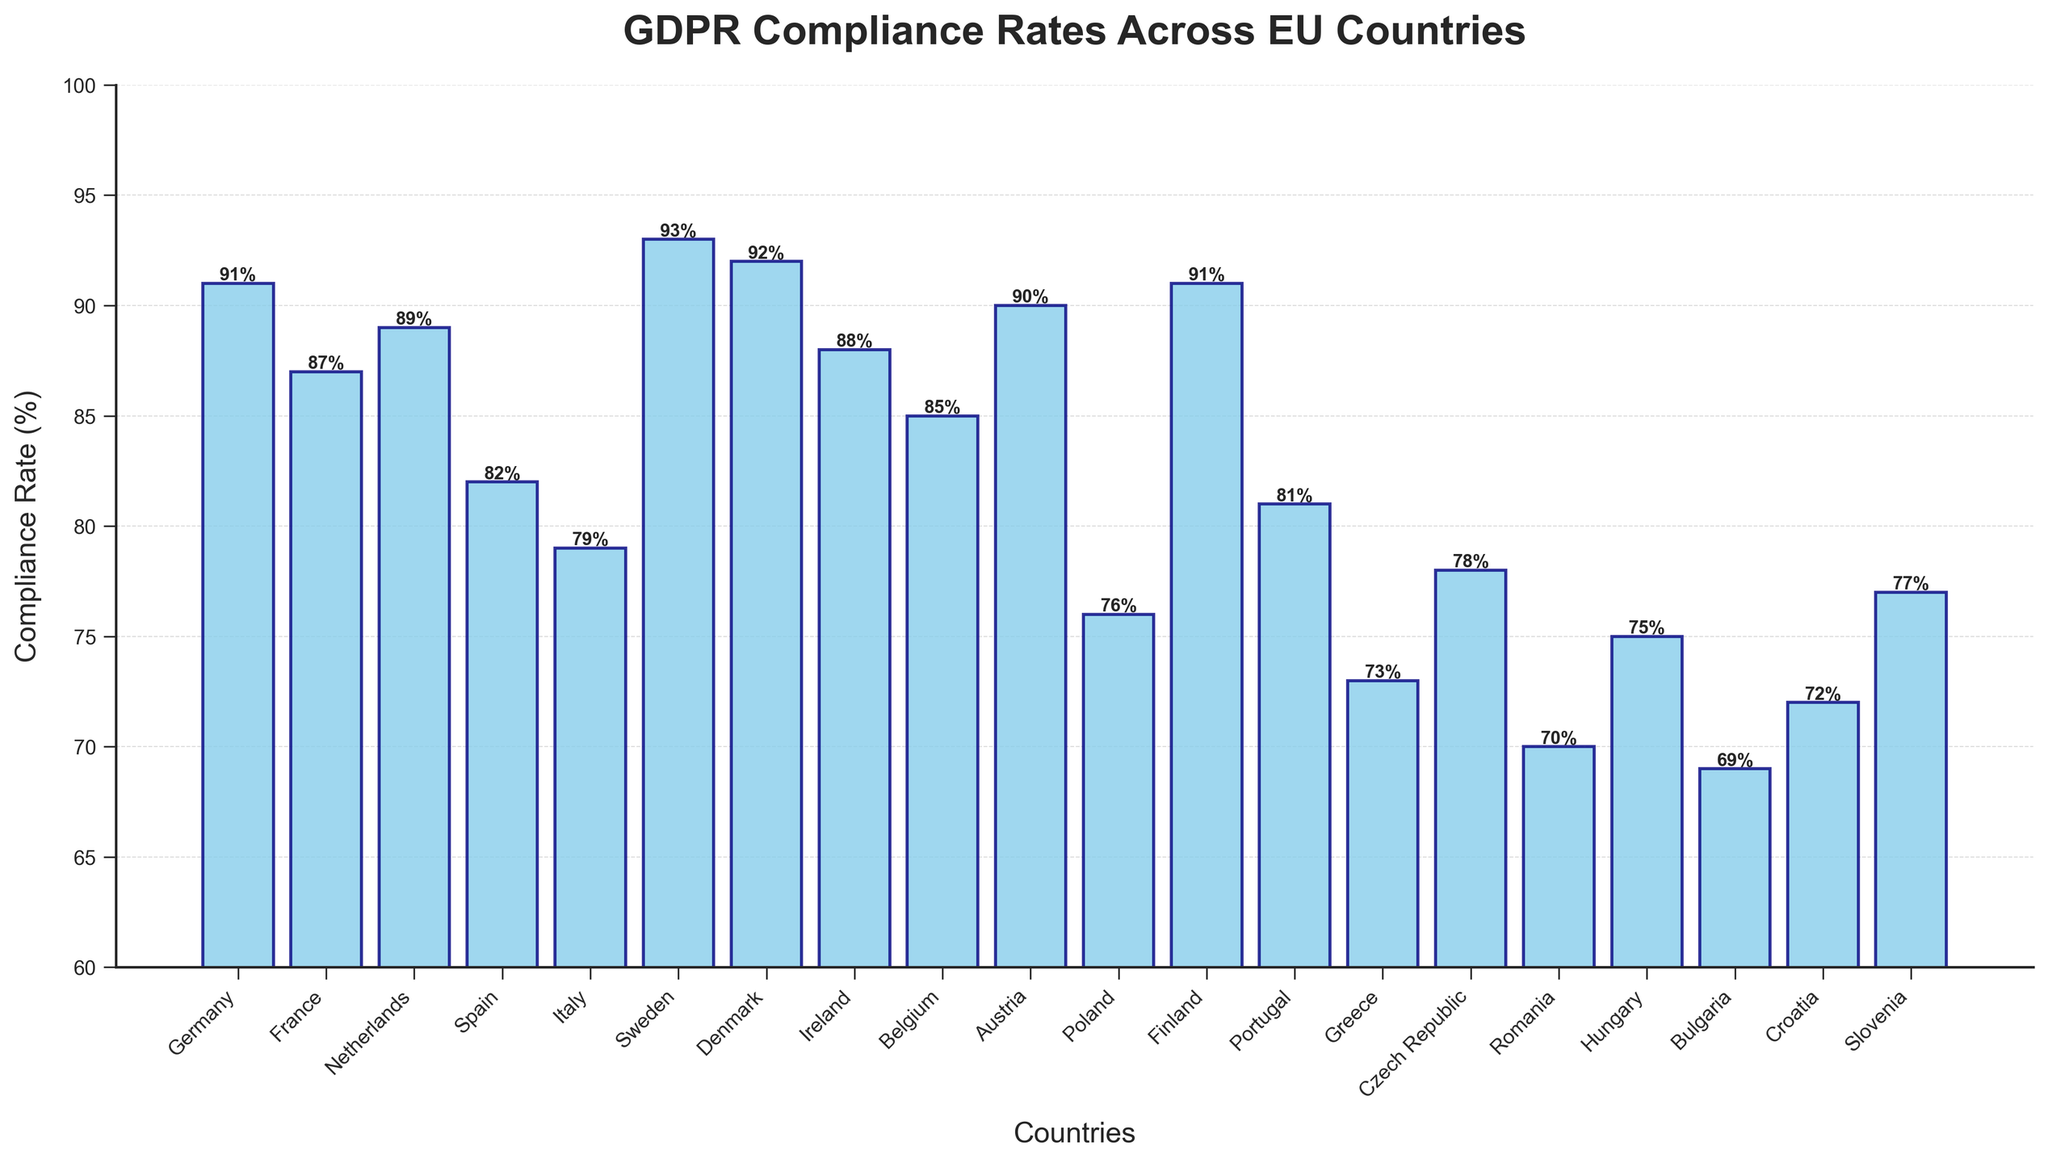Which country has the highest GDPR compliance rate? To determine which country has the highest compliance rate, look at the height of the bars and find the tallest bar. Sweden has the highest bar with a compliance rate of 93%.
Answer: Sweden Which country has the lowest GDPR compliance rate? To find the country with the lowest compliance rate, look at the shortest bar. Bulgaria has the shortest bar with a compliance rate of 69%.
Answer: Bulgaria What is the average GDPR compliance rate across all countries? Sum all the compliance rates and divide by the number of countries: (91 + 87 + 89 + 82 + 79 + 93 + 92 + 88 + 85 + 90 + 76 + 91 + 81 + 73 + 78 + 70 + 75 + 69 + 72 + 77) / 20 = 82.15%
Answer: 82.15% How many countries have a GDPR compliance rate of 90% or higher? Count the bars that have a compliance rate of 90% or higher: Germany, Sweden, Denmark, Austria, and Finland. There are 5 countries.
Answer: 5 Which country has a compliance rate closest to the average? The average compliance rate is 82.15%. France has a compliance rate of 87%, which is closest to the average.
Answer: France Which countries have a GDPR compliance rate above the EU average? First, find the average rate, which is 82.15%. Then, identify bars with heights greater than 82.15%: Germany, France, Netherlands, Sweden, Denmark, Ireland, Belgium, Austria, Finland.
Answer: Germany, France, Netherlands, Sweden, Denmark, Ireland, Belgium, Austria, Finland Which country has a compliance rate just below 80%? Identify the bar with a compliance rate just below 80%. Italy has a rate of 79%, which is just below 80%.
Answer: Italy Compare the compliance rates of Poland and Portugal. Which country has a higher rate? Look at the heights of Poland and Portugal's bars. Poland has a compliance rate of 76%, and Portugal has a rate of 81%. Portugal has a higher rate.
Answer: Portugal What is the median GDPR compliance rate? To find the median, list all rates in ascending order and find the middle value. The sorted rates are (69, 70, 72, 73, 75, 76, 77, 78, 79, 81, 82, 85, 87, 88, 89, 90, 91, 91, 92, 93). The middle values are 82 and 85, so the median is (82+85)/2 = 83.5%.
Answer: 83.5% How much higher is Sweden's compliance rate compared to Bulgaria's? Subtract Bulgaria's compliance rate from Sweden's: 93% - 69% = 24%.
Answer: 24% 